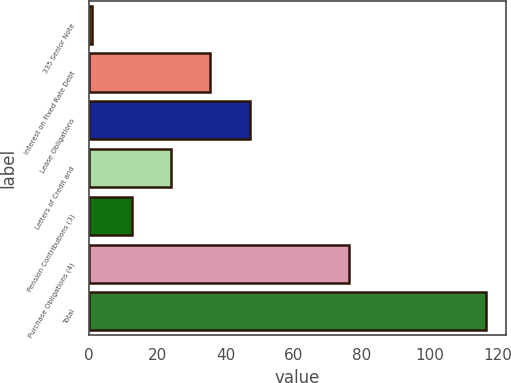Convert chart to OTSL. <chart><loc_0><loc_0><loc_500><loc_500><bar_chart><fcel>335 Senior Note<fcel>Interest on Fixed Rate Debt<fcel>Lease Obligations<fcel>Letters of Credit and<fcel>Pension Contributions (3)<fcel>Purchase Obligations (4)<fcel>Total<nl><fcel>0.87<fcel>35.58<fcel>47.15<fcel>24.01<fcel>12.44<fcel>76.4<fcel>116.6<nl></chart> 